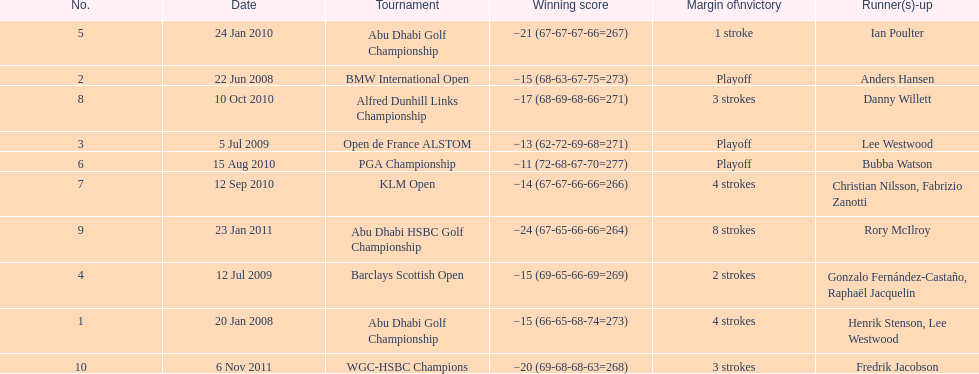How many successful scores were under -14? 2. 